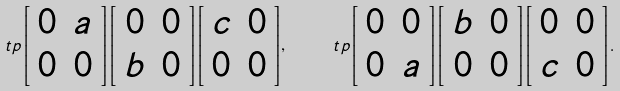Convert formula to latex. <formula><loc_0><loc_0><loc_500><loc_500>\ t p { \left [ \begin{array} { c c } 0 & a \\ 0 & 0 \end{array} \right ] } { \left [ \begin{array} { c c } 0 & 0 \\ b & 0 \end{array} \right ] } { \left [ \begin{array} { c c } c & 0 \\ 0 & 0 \end{array} \right ] } , \quad \ t p { \left [ \begin{array} { c c } 0 & 0 \\ 0 & a \end{array} \right ] } { \left [ \begin{array} { c c } b & 0 \\ 0 & 0 \end{array} \right ] } { \left [ \begin{array} { c c } 0 & 0 \\ c & 0 \end{array} \right ] } .</formula> 